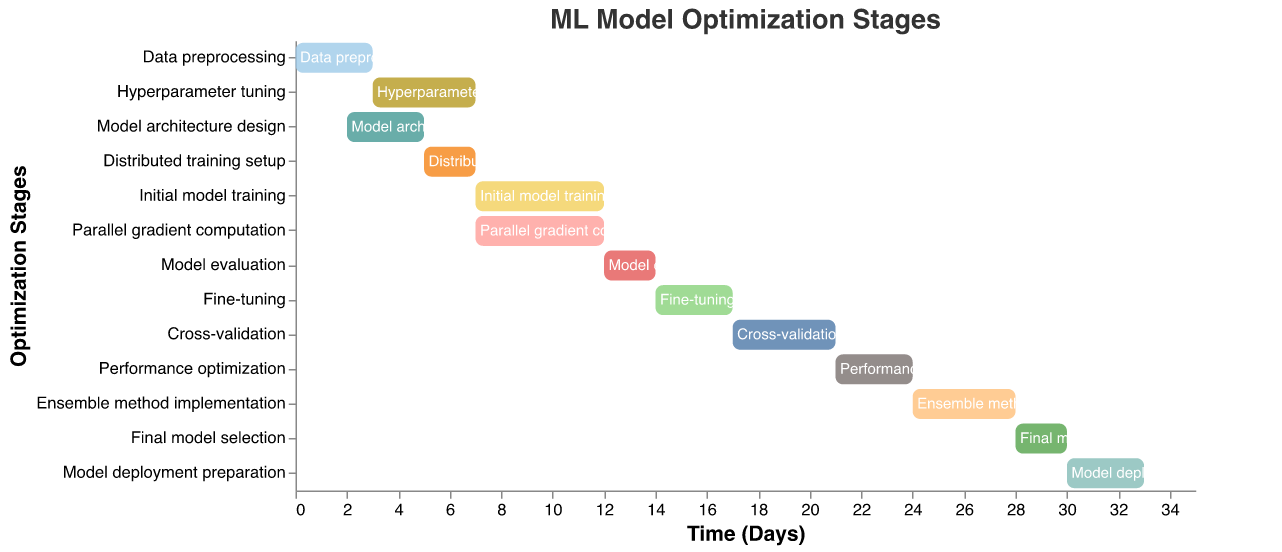What is the title of the Gantt Chart? The title of the chart is located at the top in the center. It reads, "ML Model Optimization Stages".
Answer: ML Model Optimization Stages How many tasks are displayed in the Gantt Chart? By counting the number of distinct tasks listed along the y-axis, we see that there are 13 tasks.
Answer: 13 At what time does the "Distributed training setup" task finish? The "Distributed training setup" starts at day 5 and has a duration of 2 days. Adding the duration to the start time gives 5 + 2 = 7.
Answer: 7 Which tasks are performed in parallel starting from day 7? Looking at the tasks that begin at day 7, both "Initial model training" and "Parallel gradient computation" start at the same time.
Answer: Initial model training and Parallel gradient computation What's the total duration of the "Cross-validation" task? The chart shows that "Cross-validation" starts at day 17 and lasts for 4 days.
Answer: 4 days Which task comes immediately before "Model deployment preparation"? By examining the sequence of tasks and their end times, "Final model selection" ends at day 30, which aligns with the start of "Model deployment preparation".
Answer: Final model selection Between "Hyperparameter tuning" and "Fine-tuning", which task has a longer duration? "Hyperparameter tuning" has a duration of 4 days, and "Fine-tuning" has a duration of 3 days. Therefore, "Hyperparameter tuning" is longer.
Answer: Hyperparameter tuning When does the "Model evaluation" task start and end? "Model evaluation" starts at day 12 and has a duration of 2 days, so it ends at 12 + 2 = 14.
Answer: Starts at day 12 and ends at day 14 What is the duration difference between "Initial model training" and "Model deployment preparation"? "Initial model training" has a duration of 5 days, while "Model deployment preparation" has a duration of 3 days. The difference is 5 - 3 = 2 days.
Answer: 2 days Among all the tasks, which one has the longest duration? By comparing the durations of each task, both "Initial model training" and "Parallel gradient computation" have the longest duration of 5 days.
Answer: Initial model training and Parallel gradient computation 